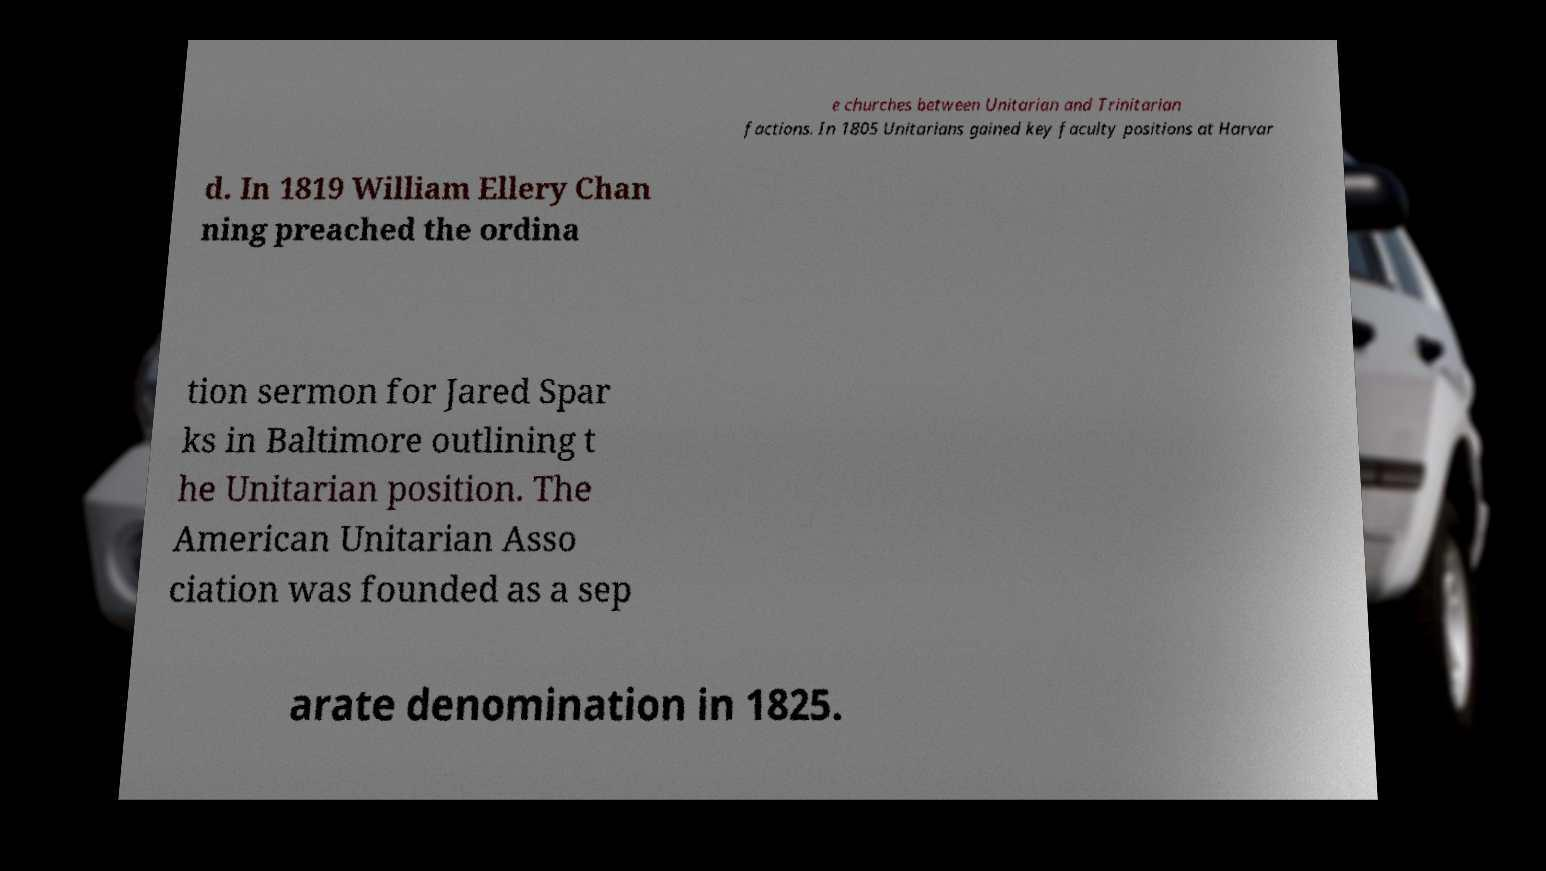Can you accurately transcribe the text from the provided image for me? e churches between Unitarian and Trinitarian factions. In 1805 Unitarians gained key faculty positions at Harvar d. In 1819 William Ellery Chan ning preached the ordina tion sermon for Jared Spar ks in Baltimore outlining t he Unitarian position. The American Unitarian Asso ciation was founded as a sep arate denomination in 1825. 